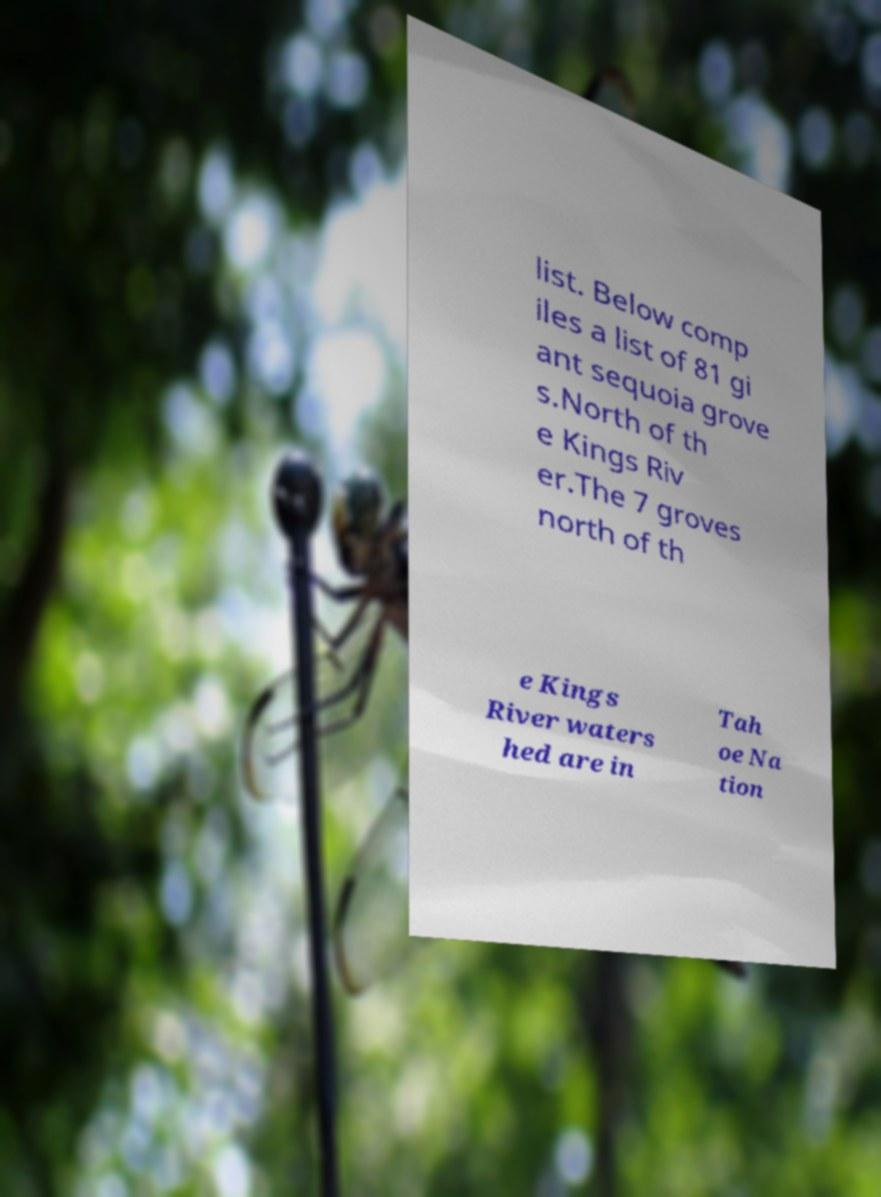Could you assist in decoding the text presented in this image and type it out clearly? list. Below comp iles a list of 81 gi ant sequoia grove s.North of th e Kings Riv er.The 7 groves north of th e Kings River waters hed are in Tah oe Na tion 